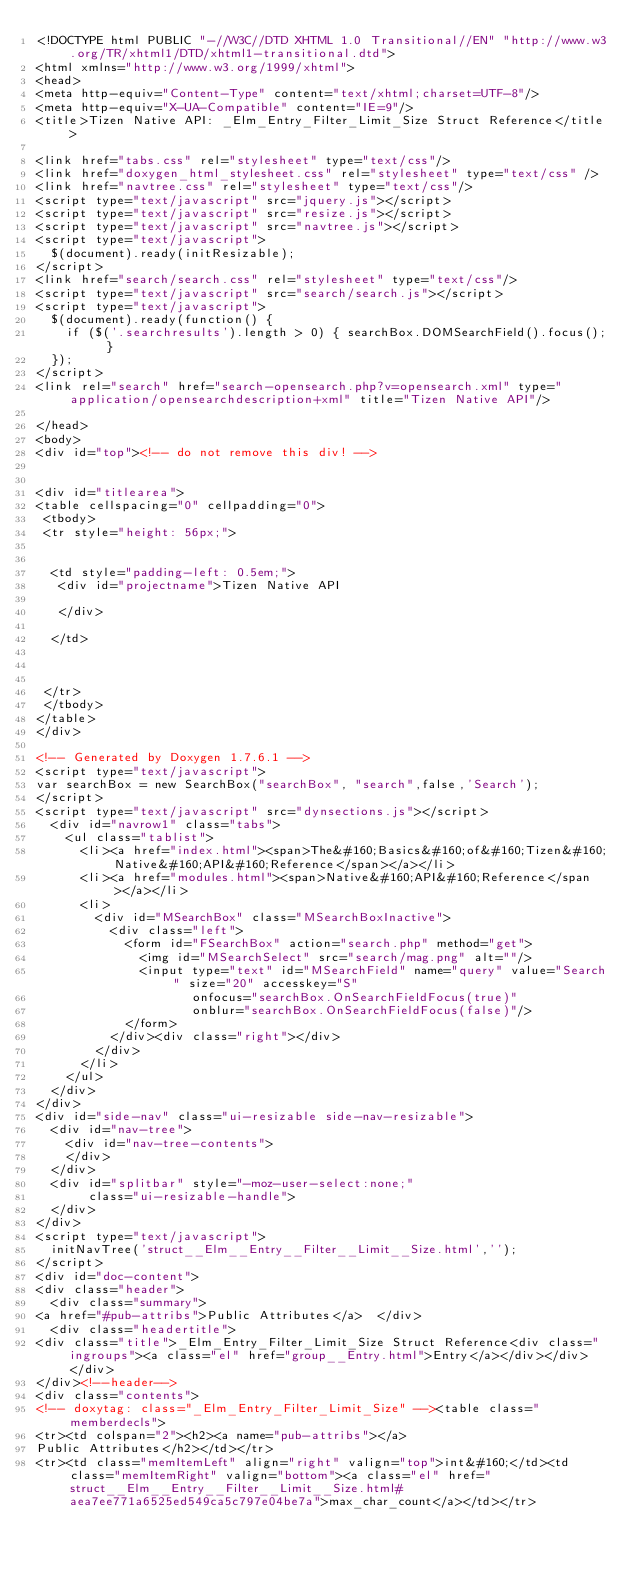Convert code to text. <code><loc_0><loc_0><loc_500><loc_500><_HTML_><!DOCTYPE html PUBLIC "-//W3C//DTD XHTML 1.0 Transitional//EN" "http://www.w3.org/TR/xhtml1/DTD/xhtml1-transitional.dtd">
<html xmlns="http://www.w3.org/1999/xhtml">
<head>
<meta http-equiv="Content-Type" content="text/xhtml;charset=UTF-8"/>
<meta http-equiv="X-UA-Compatible" content="IE=9"/>
<title>Tizen Native API: _Elm_Entry_Filter_Limit_Size Struct Reference</title>

<link href="tabs.css" rel="stylesheet" type="text/css"/>
<link href="doxygen_html_stylesheet.css" rel="stylesheet" type="text/css" />
<link href="navtree.css" rel="stylesheet" type="text/css"/>
<script type="text/javascript" src="jquery.js"></script>
<script type="text/javascript" src="resize.js"></script>
<script type="text/javascript" src="navtree.js"></script>
<script type="text/javascript">
  $(document).ready(initResizable);
</script>
<link href="search/search.css" rel="stylesheet" type="text/css"/>
<script type="text/javascript" src="search/search.js"></script>
<script type="text/javascript">
  $(document).ready(function() {
    if ($('.searchresults').length > 0) { searchBox.DOMSearchField().focus(); }
  });
</script>
<link rel="search" href="search-opensearch.php?v=opensearch.xml" type="application/opensearchdescription+xml" title="Tizen Native API"/>

</head>
<body>
<div id="top"><!-- do not remove this div! -->


<div id="titlearea">
<table cellspacing="0" cellpadding="0">
 <tbody>
 <tr style="height: 56px;">
  
  
  <td style="padding-left: 0.5em;">
   <div id="projectname">Tizen Native API
   
   </div>
   
  </td>
  
  
  
 </tr>
 </tbody>
</table>
</div>

<!-- Generated by Doxygen 1.7.6.1 -->
<script type="text/javascript">
var searchBox = new SearchBox("searchBox", "search",false,'Search');
</script>
<script type="text/javascript" src="dynsections.js"></script>
  <div id="navrow1" class="tabs">
    <ul class="tablist">
      <li><a href="index.html"><span>The&#160;Basics&#160;of&#160;Tizen&#160;Native&#160;API&#160;Reference</span></a></li>
      <li><a href="modules.html"><span>Native&#160;API&#160;Reference</span></a></li>
      <li>
        <div id="MSearchBox" class="MSearchBoxInactive">
          <div class="left">
            <form id="FSearchBox" action="search.php" method="get">
              <img id="MSearchSelect" src="search/mag.png" alt=""/>
              <input type="text" id="MSearchField" name="query" value="Search" size="20" accesskey="S" 
                     onfocus="searchBox.OnSearchFieldFocus(true)" 
                     onblur="searchBox.OnSearchFieldFocus(false)"/>
            </form>
          </div><div class="right"></div>
        </div>
      </li>
    </ul>
  </div>
</div>
<div id="side-nav" class="ui-resizable side-nav-resizable">
  <div id="nav-tree">
    <div id="nav-tree-contents">
    </div>
  </div>
  <div id="splitbar" style="-moz-user-select:none;" 
       class="ui-resizable-handle">
  </div>
</div>
<script type="text/javascript">
  initNavTree('struct__Elm__Entry__Filter__Limit__Size.html','');
</script>
<div id="doc-content">
<div class="header">
  <div class="summary">
<a href="#pub-attribs">Public Attributes</a>  </div>
  <div class="headertitle">
<div class="title">_Elm_Entry_Filter_Limit_Size Struct Reference<div class="ingroups"><a class="el" href="group__Entry.html">Entry</a></div></div>  </div>
</div><!--header-->
<div class="contents">
<!-- doxytag: class="_Elm_Entry_Filter_Limit_Size" --><table class="memberdecls">
<tr><td colspan="2"><h2><a name="pub-attribs"></a>
Public Attributes</h2></td></tr>
<tr><td class="memItemLeft" align="right" valign="top">int&#160;</td><td class="memItemRight" valign="bottom"><a class="el" href="struct__Elm__Entry__Filter__Limit__Size.html#aea7ee771a6525ed549ca5c797e04be7a">max_char_count</a></td></tr></code> 